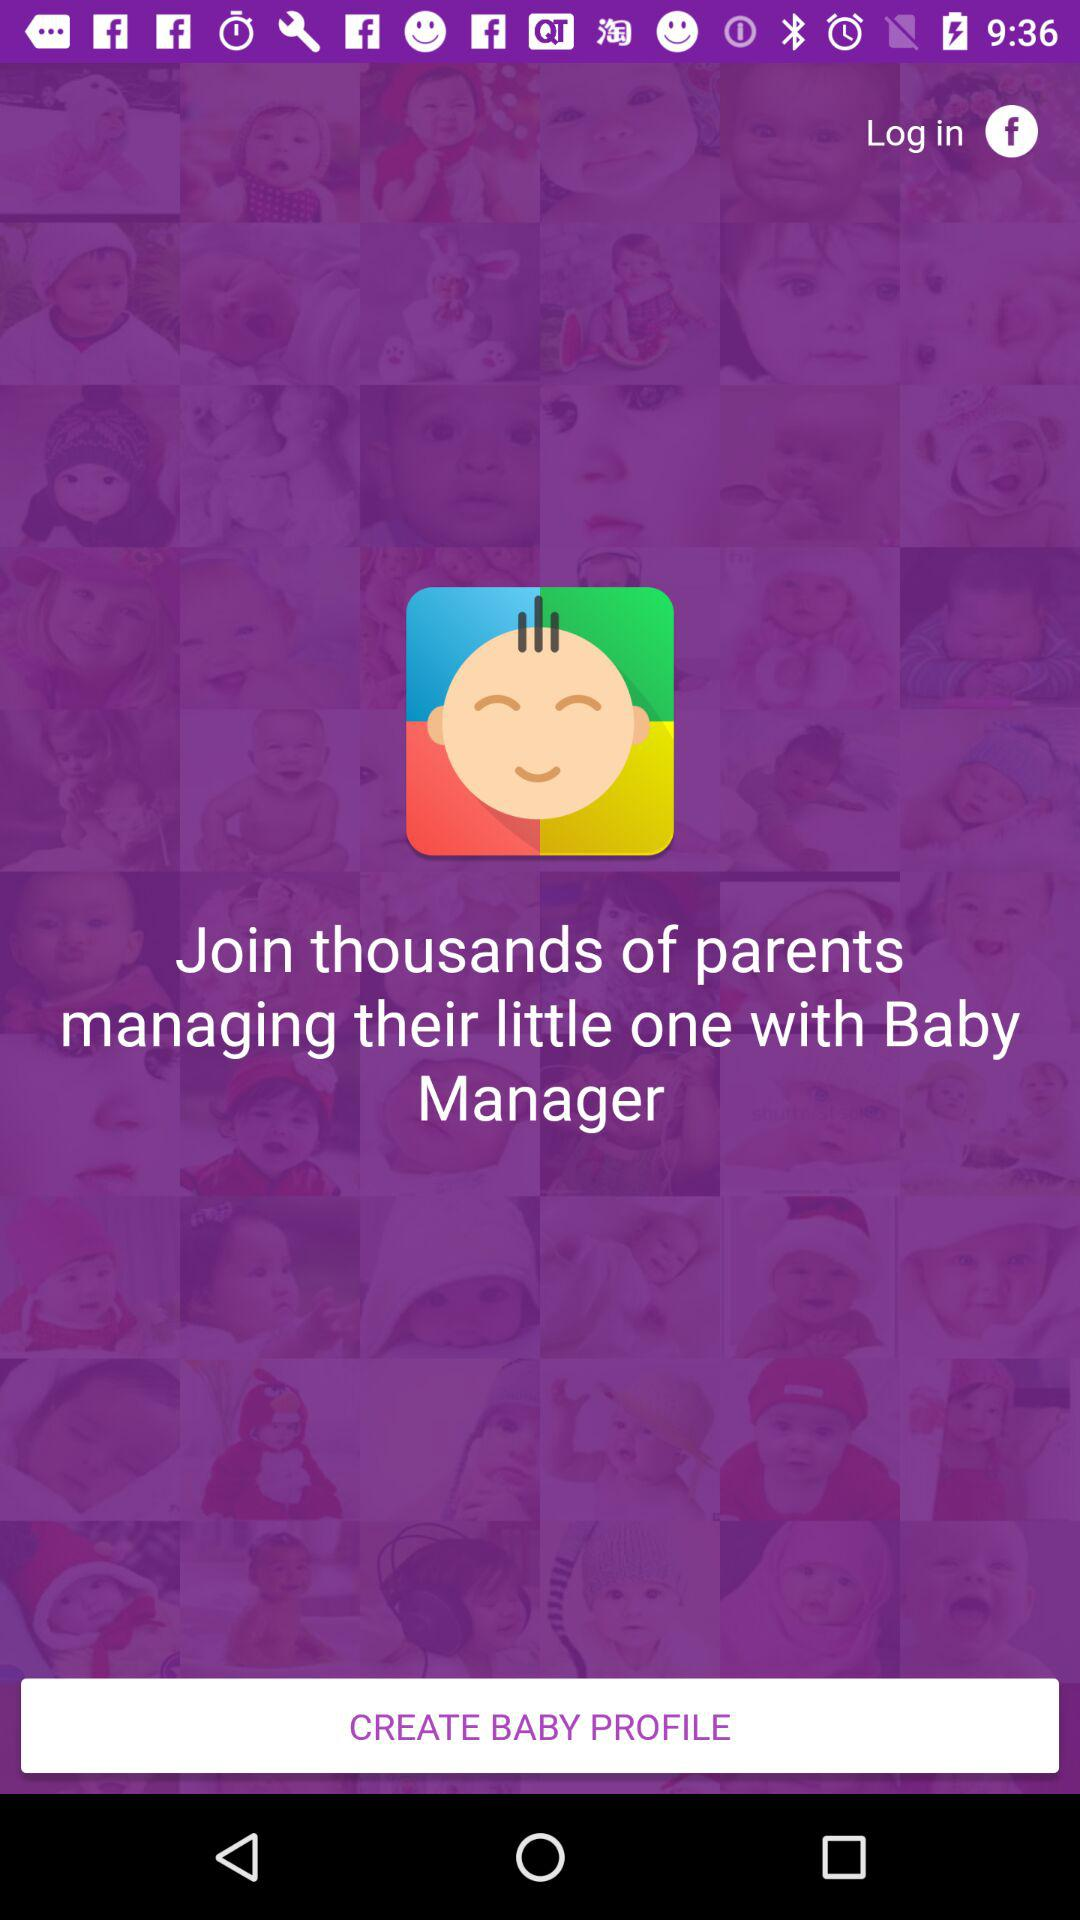What is the name of the application? The name of the application is "Baby Manager". 